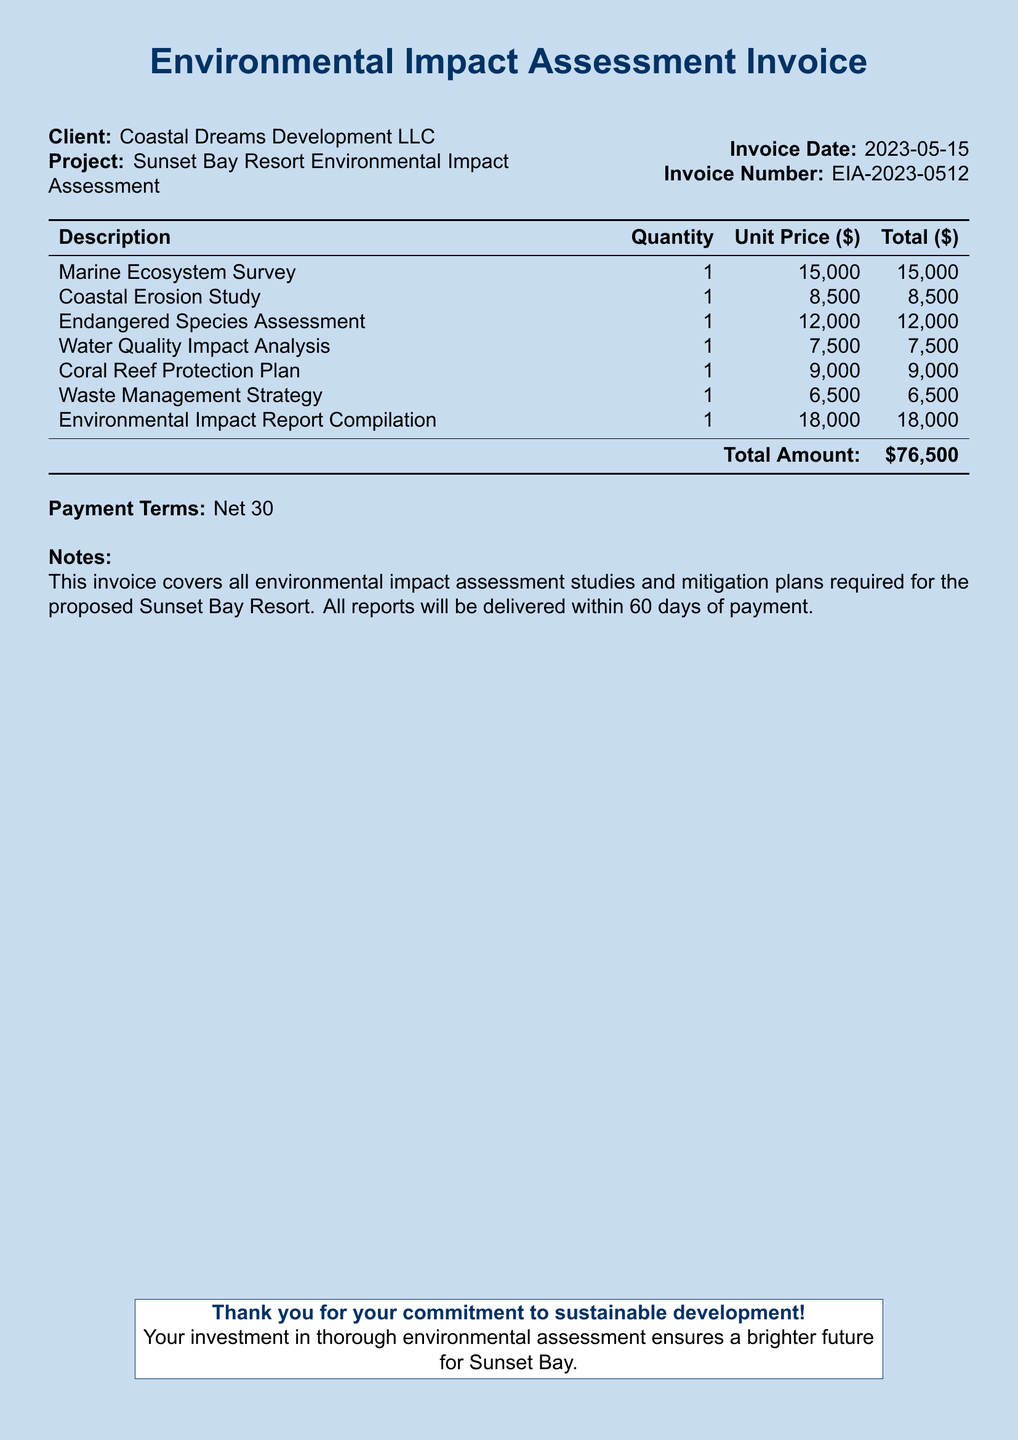what is the invoice number? The invoice number is listed in the document as a unique identifier for this invoice.
Answer: EIA-2023-0512 who is the client? The client is mentioned at the beginning of the document as the entity receiving the services.
Answer: Coastal Dreams Development LLC what is the total amount due? The total amount is calculated from the sum of all study costs listed in the invoice.
Answer: $76,500 how many studies are listed in the invoice? The number of studies can be determined by counting the description entries in the table.
Answer: 6 what is the payment term specified? Payment terms indicate the time frame allowed for payment before penalties occur, which is detailed in the notes section.
Answer: Net 30 what study has the highest cost? The highest cost study can be identified by comparing the unit prices of all listed studies in the invoice.
Answer: Environmental Impact Report Compilation how long will it take to deliver the reports? The delivery time for the reports is specified in the notes section of the document.
Answer: 60 days which project does this invoice pertain to? The project name is explicitly stated at the start of the document in relation to the client.
Answer: Sunset Bay Resort Environmental Impact Assessment what is included in the Waste Management Strategy cost? This involves a specific ecological study as outlined in the invoice detailing its purpose and cost.
Answer: $6,500 